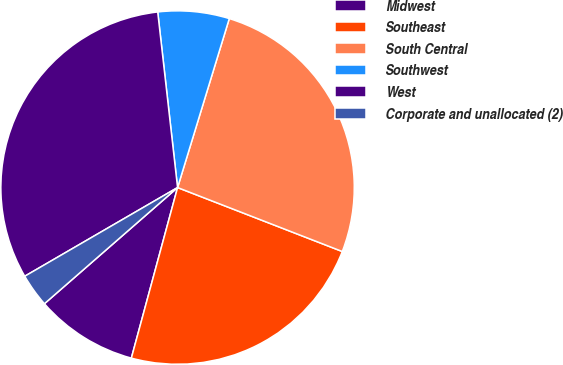<chart> <loc_0><loc_0><loc_500><loc_500><pie_chart><fcel>Midwest<fcel>Southeast<fcel>South Central<fcel>Southwest<fcel>West<fcel>Corporate and unallocated (2)<nl><fcel>9.37%<fcel>23.32%<fcel>26.17%<fcel>6.52%<fcel>31.58%<fcel>3.05%<nl></chart> 